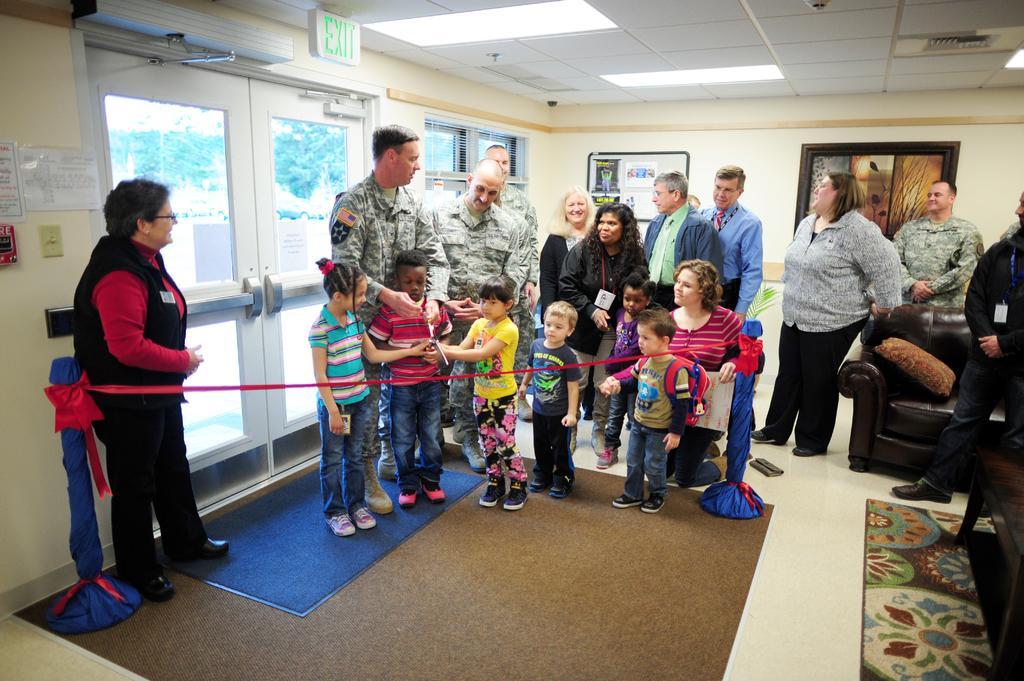Describe this image in one or two sentences. In this picture I can see group of people standing. There is a pillow on the couch, carpets and some other objects. I can see papers and boards attached to the walls. I can see window and a door. Through the door I can see trees. 